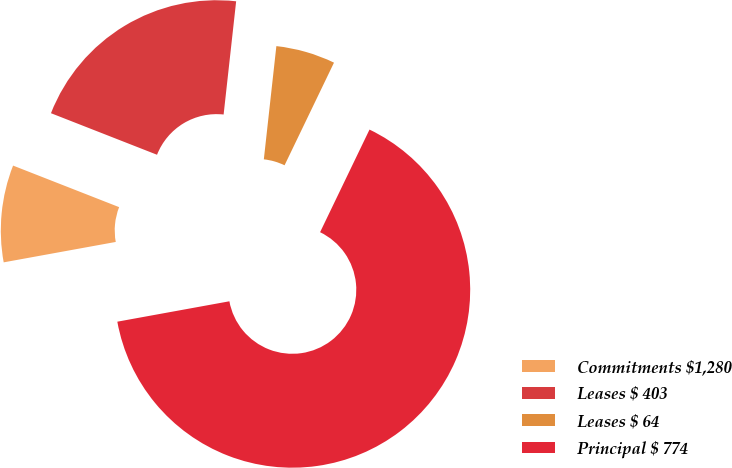Convert chart to OTSL. <chart><loc_0><loc_0><loc_500><loc_500><pie_chart><fcel>Commitments $1,280<fcel>Leases $ 403<fcel>Leases $ 64<fcel>Principal $ 774<nl><fcel>8.81%<fcel>20.81%<fcel>5.39%<fcel>64.99%<nl></chart> 